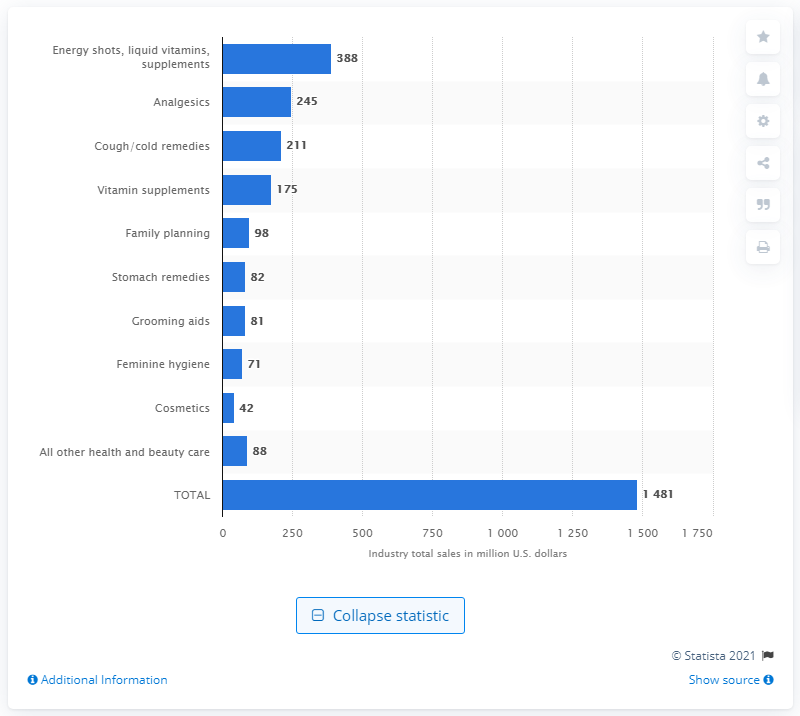Identify some key points in this picture. In 2013, a total of 211 dollars were spent on cough and cold remedies in convenience stores. 